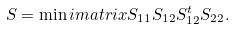<formula> <loc_0><loc_0><loc_500><loc_500>S = \min i m a t r i x { S _ { 1 1 } } { S _ { 1 2 } } { S _ { 1 2 } ^ { t } } { S _ { 2 2 } } .</formula> 